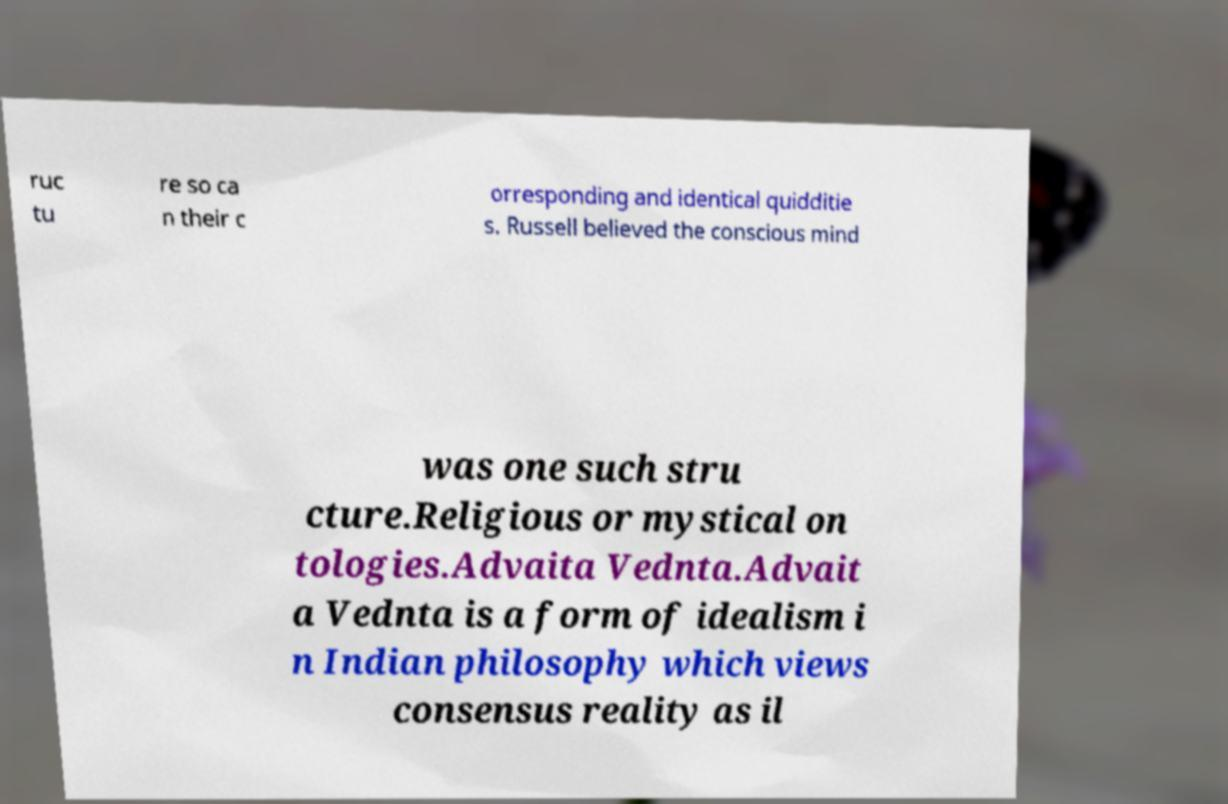Can you accurately transcribe the text from the provided image for me? ruc tu re so ca n their c orresponding and identical quidditie s. Russell believed the conscious mind was one such stru cture.Religious or mystical on tologies.Advaita Vednta.Advait a Vednta is a form of idealism i n Indian philosophy which views consensus reality as il 